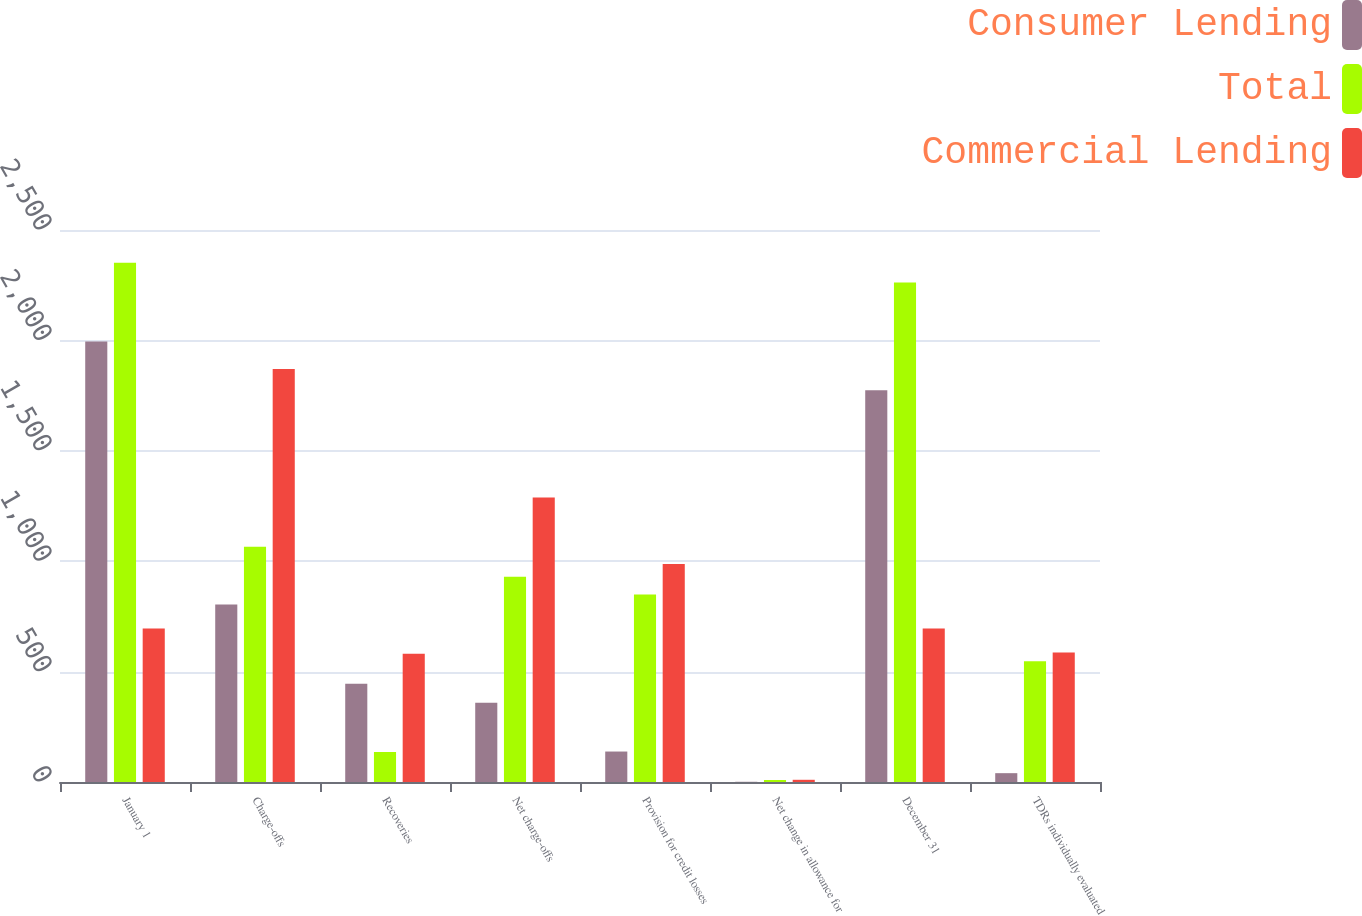<chart> <loc_0><loc_0><loc_500><loc_500><stacked_bar_chart><ecel><fcel>January 1<fcel>Charge-offs<fcel>Recoveries<fcel>Net charge-offs<fcel>Provision for credit losses<fcel>Net change in allowance for<fcel>December 31<fcel>TDRs individually evaluated<nl><fcel>Consumer Lending<fcel>1995<fcel>804<fcel>445<fcel>359<fcel>138<fcel>1<fcel>1774<fcel>40<nl><fcel>Total<fcel>2352<fcel>1066<fcel>136<fcel>930<fcel>849<fcel>9<fcel>2262<fcel>547<nl><fcel>Commercial Lending<fcel>695.5<fcel>1870<fcel>581<fcel>1289<fcel>987<fcel>10<fcel>695.5<fcel>587<nl></chart> 